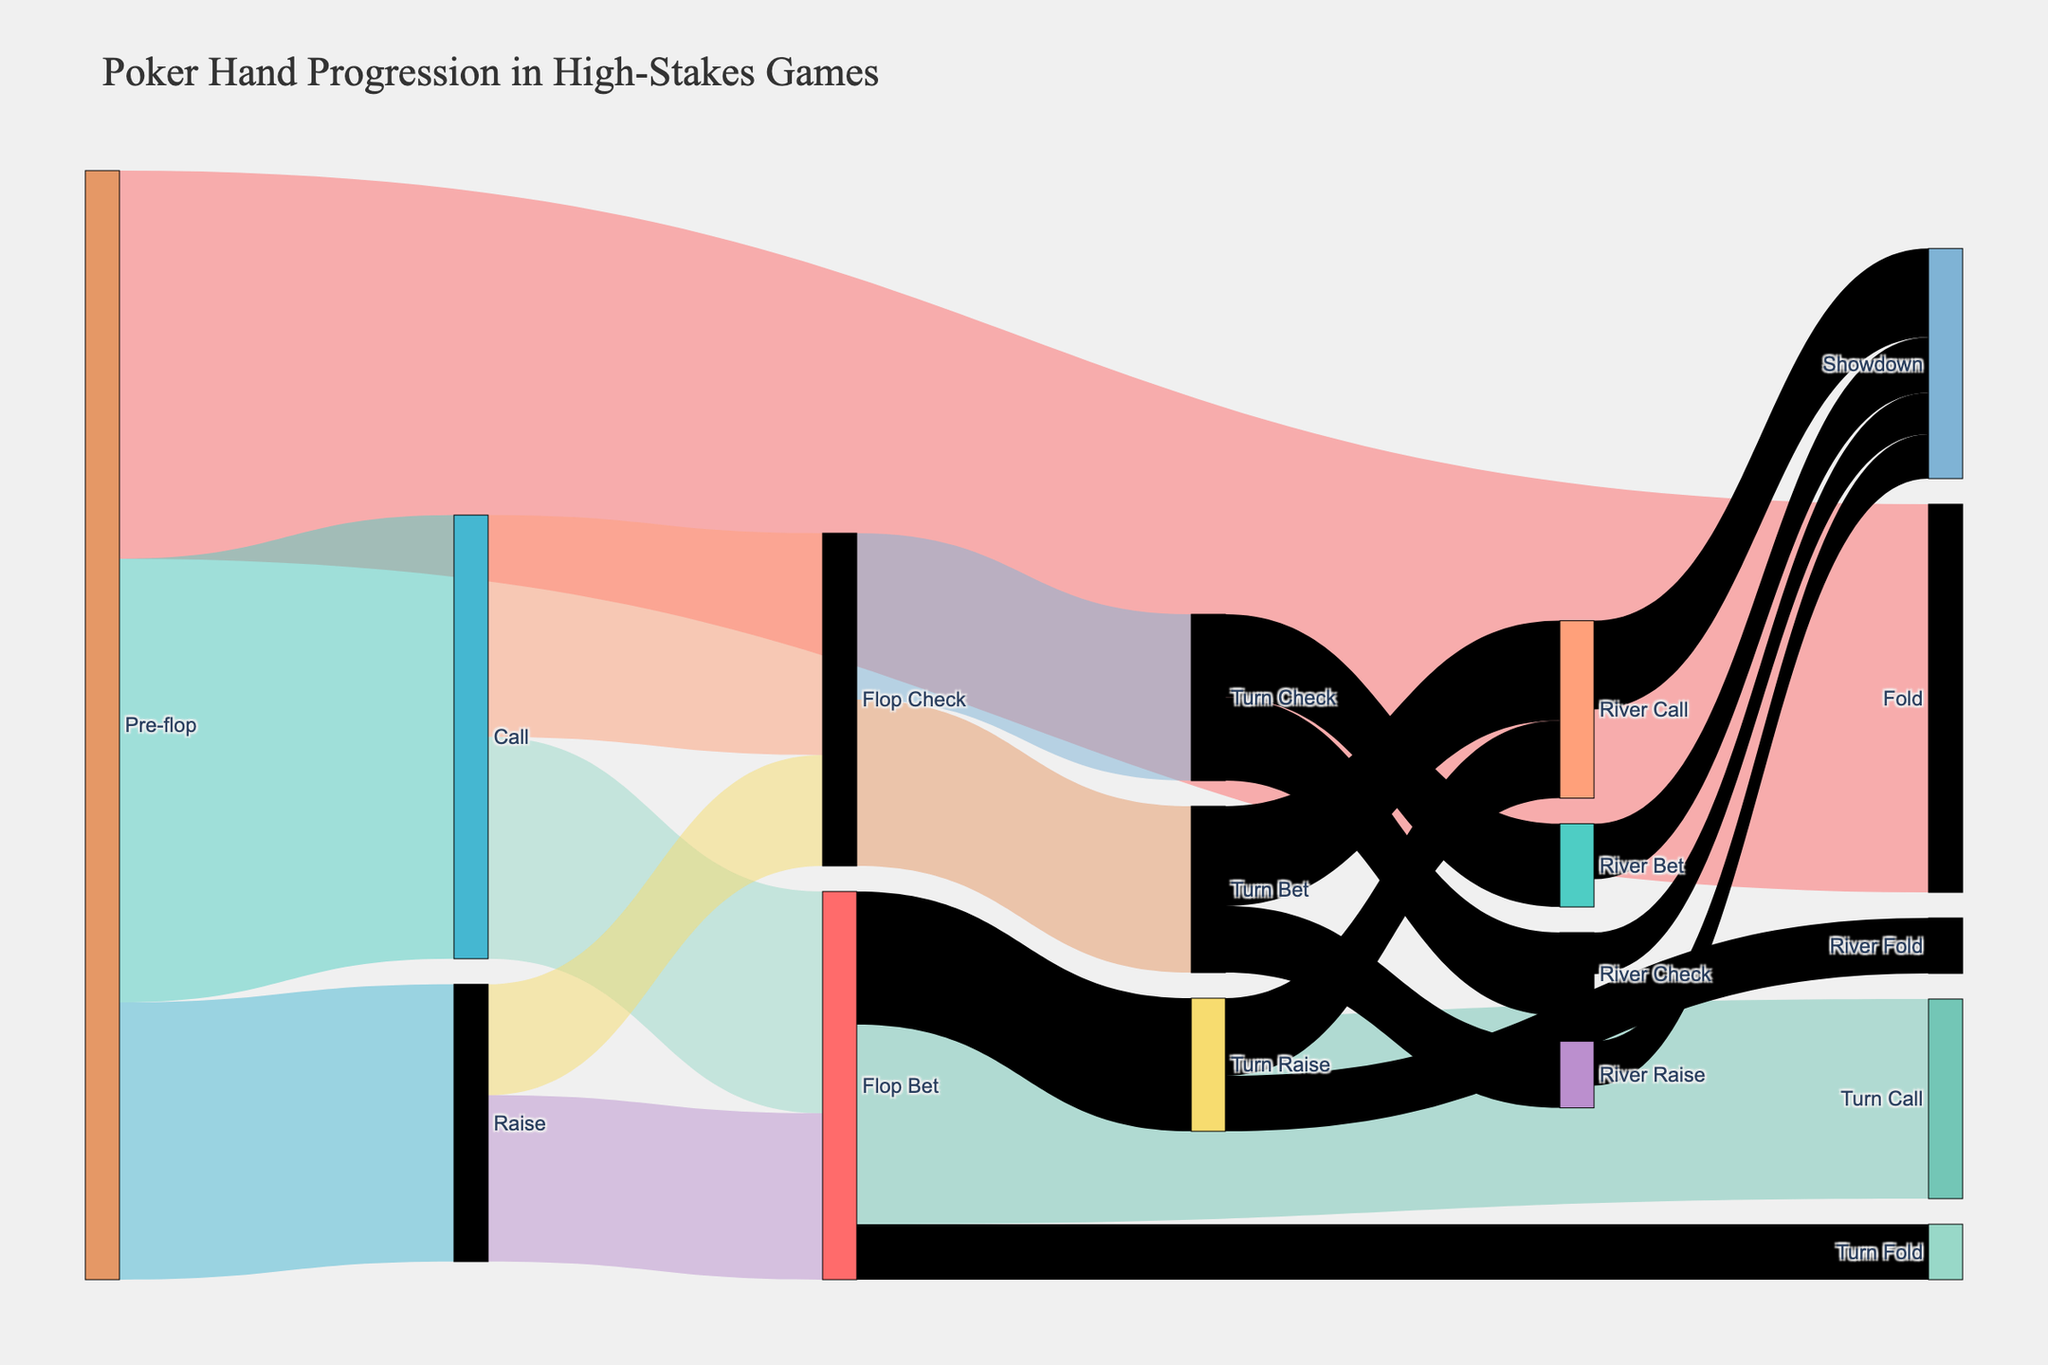what is the title of the figure? The title of the figure is usually found at the top of the Sankey diagram and indicates what the diagram represents. In this case, the title of the figure is "Poker Hand Progression in High-Stakes Games".
Answer: Poker Hand Progression in High-Stakes Games What happens most frequently during the pre-flop stage? To determine what happens most frequently, we need to look at the values associated with each target from "Pre-flop". The options are Fold (3500), Call (4000), and Raise (2500). The highest value is 4000 for Call.
Answer: Call How many players fold during the river stage after a turn raise? To determine this, look at the value that connects "Turn Raise" to "River Fold". The diagram shows a value of 500 for this progression.
Answer: 500 Which transition has more players: flop check to turn check or flop bet to turn fold? We need to compare the values for the transitions "Flop Check" to "Turn Check" and "Flop Bet" to "Turn Fold". "Flop Check" to "Turn Check" has a value of 1500, while "Flop Bet" to "Turn Fold" has a value of 500. Thus, "Flop Check" to "Turn Check" has more players.
Answer: Flop Check to Turn Check What is the total number of players who go from turn bet to river call or river raise? We need to add the values for "Turn Bet" to "River Call" (900) and "Turn Bet" to "River Raise" (600). The total is 900 + 600.
Answer: 1500 Which river outcome has the highest number of players? River outcomes include "River Check", "River Bet", "River Call", and "River Raise". We need to add up all the progressions leading to "Showdown", but those are different paths leading to the final showdown. "River Call" leading to "Showdown" has the highest value of 800.
Answer: River Call How many players proceed to showdown after a river bet? Look at the value that connects "River Bet" to "Showdown". According to the diagram, this value is 500.
Answer: 500 Compare the number of players who fold pre-flop with the number who check on the flop out of those who called pre-flop. Which is higher? "Pre-flop" to "Fold" has 3500 players. For "Call" to "Flop Check", the value is 2000. Comparatively, more players fold pre-flop than those who check on the flop after calling pre-flop.
Answer: Pre-flop Fold What is the combined number of players who continue with betting actions on the river stage? We need to add the values for "River Bet" and "River Raise" leading to "Showdown": "River Bet" (500) and "River Raise" (400) total 900.
Answer: 900 